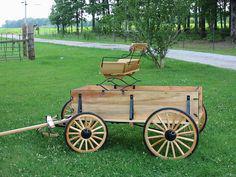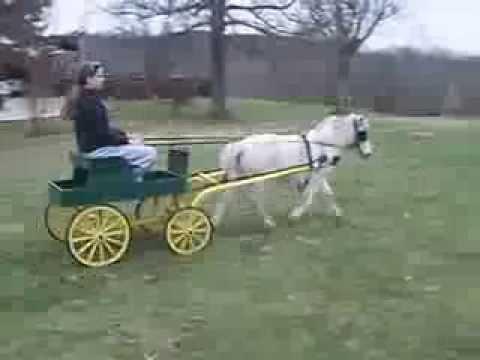The first image is the image on the left, the second image is the image on the right. Analyze the images presented: Is the assertion "The wheels in one of the images have metal spokes." valid? Answer yes or no. No. 